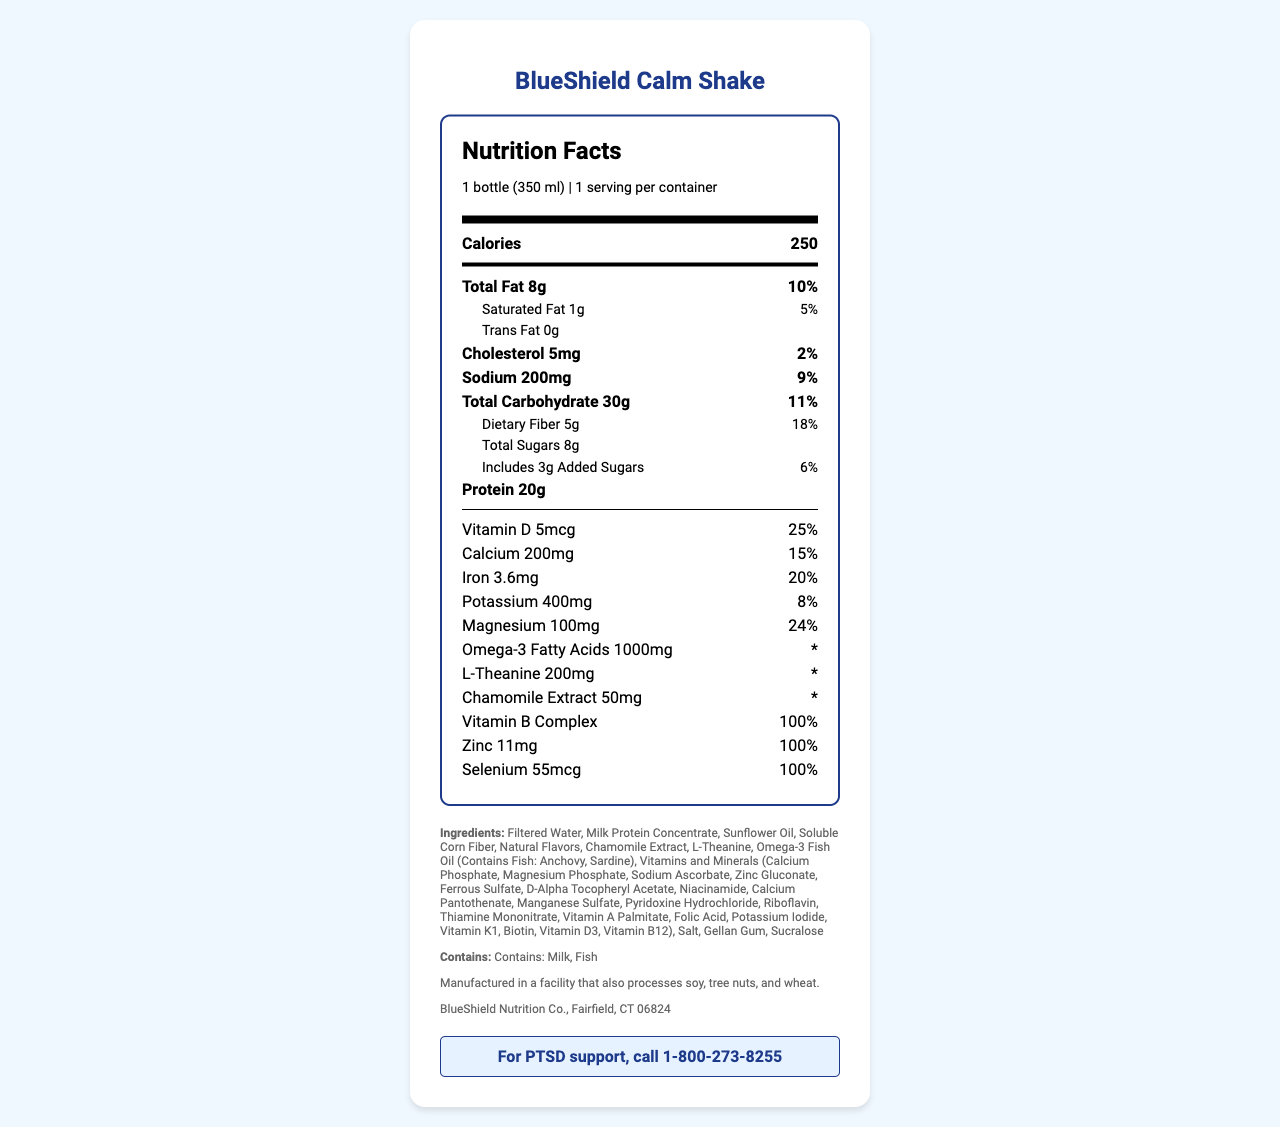what is the serving size for the BlueShield Calm Shake? The serving size is clearly stated at the top of the Nutrition Facts label as "1 bottle (350 ml)".
Answer: 1 bottle (350 ml) how many calories are in one serving? The calories per serving are prominently displayed as 250 at the top of the Nutrition Facts label.
Answer: 250 how much protein does one bottle contain? Under the nutrition items, it lists "Protein 20g" indicating that each bottle contains 20 grams of protein.
Answer: 20g what is the daily value percentage for dietary fiber? The daily value percentage for dietary fiber is listed as 18% next to the dietary fiber amount.
Answer: 18% List all allergens mentioned in the label. The allergen information section at the bottom of the Nutrition Facts label states that it "Contains: Milk, Fish".
Answer: Milk, Fish which of the following nutrients has the highest daily value percentage? A. Calcium B. Iron C. Vitamin D The daily value percentages listed are 25% for Vitamin D, 15% for Calcium, and 20% for Iron. Therefore, Vitamin D has the highest daily value percentage.
Answer: C what is the total amount of omega-3 fatty acids included in the shake? A. 500mg B. 1000mg C. 1500mg The amount of omega-3 fatty acids is explicitly stated as 1000mg next to it, making option B correct.
Answer: B does this product contain any trans fat? The label specifies "Trans Fat 0g," indicating that it does not contain any trans fat.
Answer: No briefly describe what this document provides. This document includes a comprehensive breakdown of the nutritional content, ingredient list, allergen information, and daily value percentages for various nutrients within the BlueShield Calm Shake.
Answer: The document provides a detailed Nutrition Facts label for the BlueShield Calm Shake, including nutrient amounts, daily values, allergens, and ingredient information. What is the omega-3 fatty acids daily value percentage? The daily value percentage for omega-3 fatty acids is not provided in the document; it is marked with an asterisk (*) instead.
Answer: Cannot be determined 